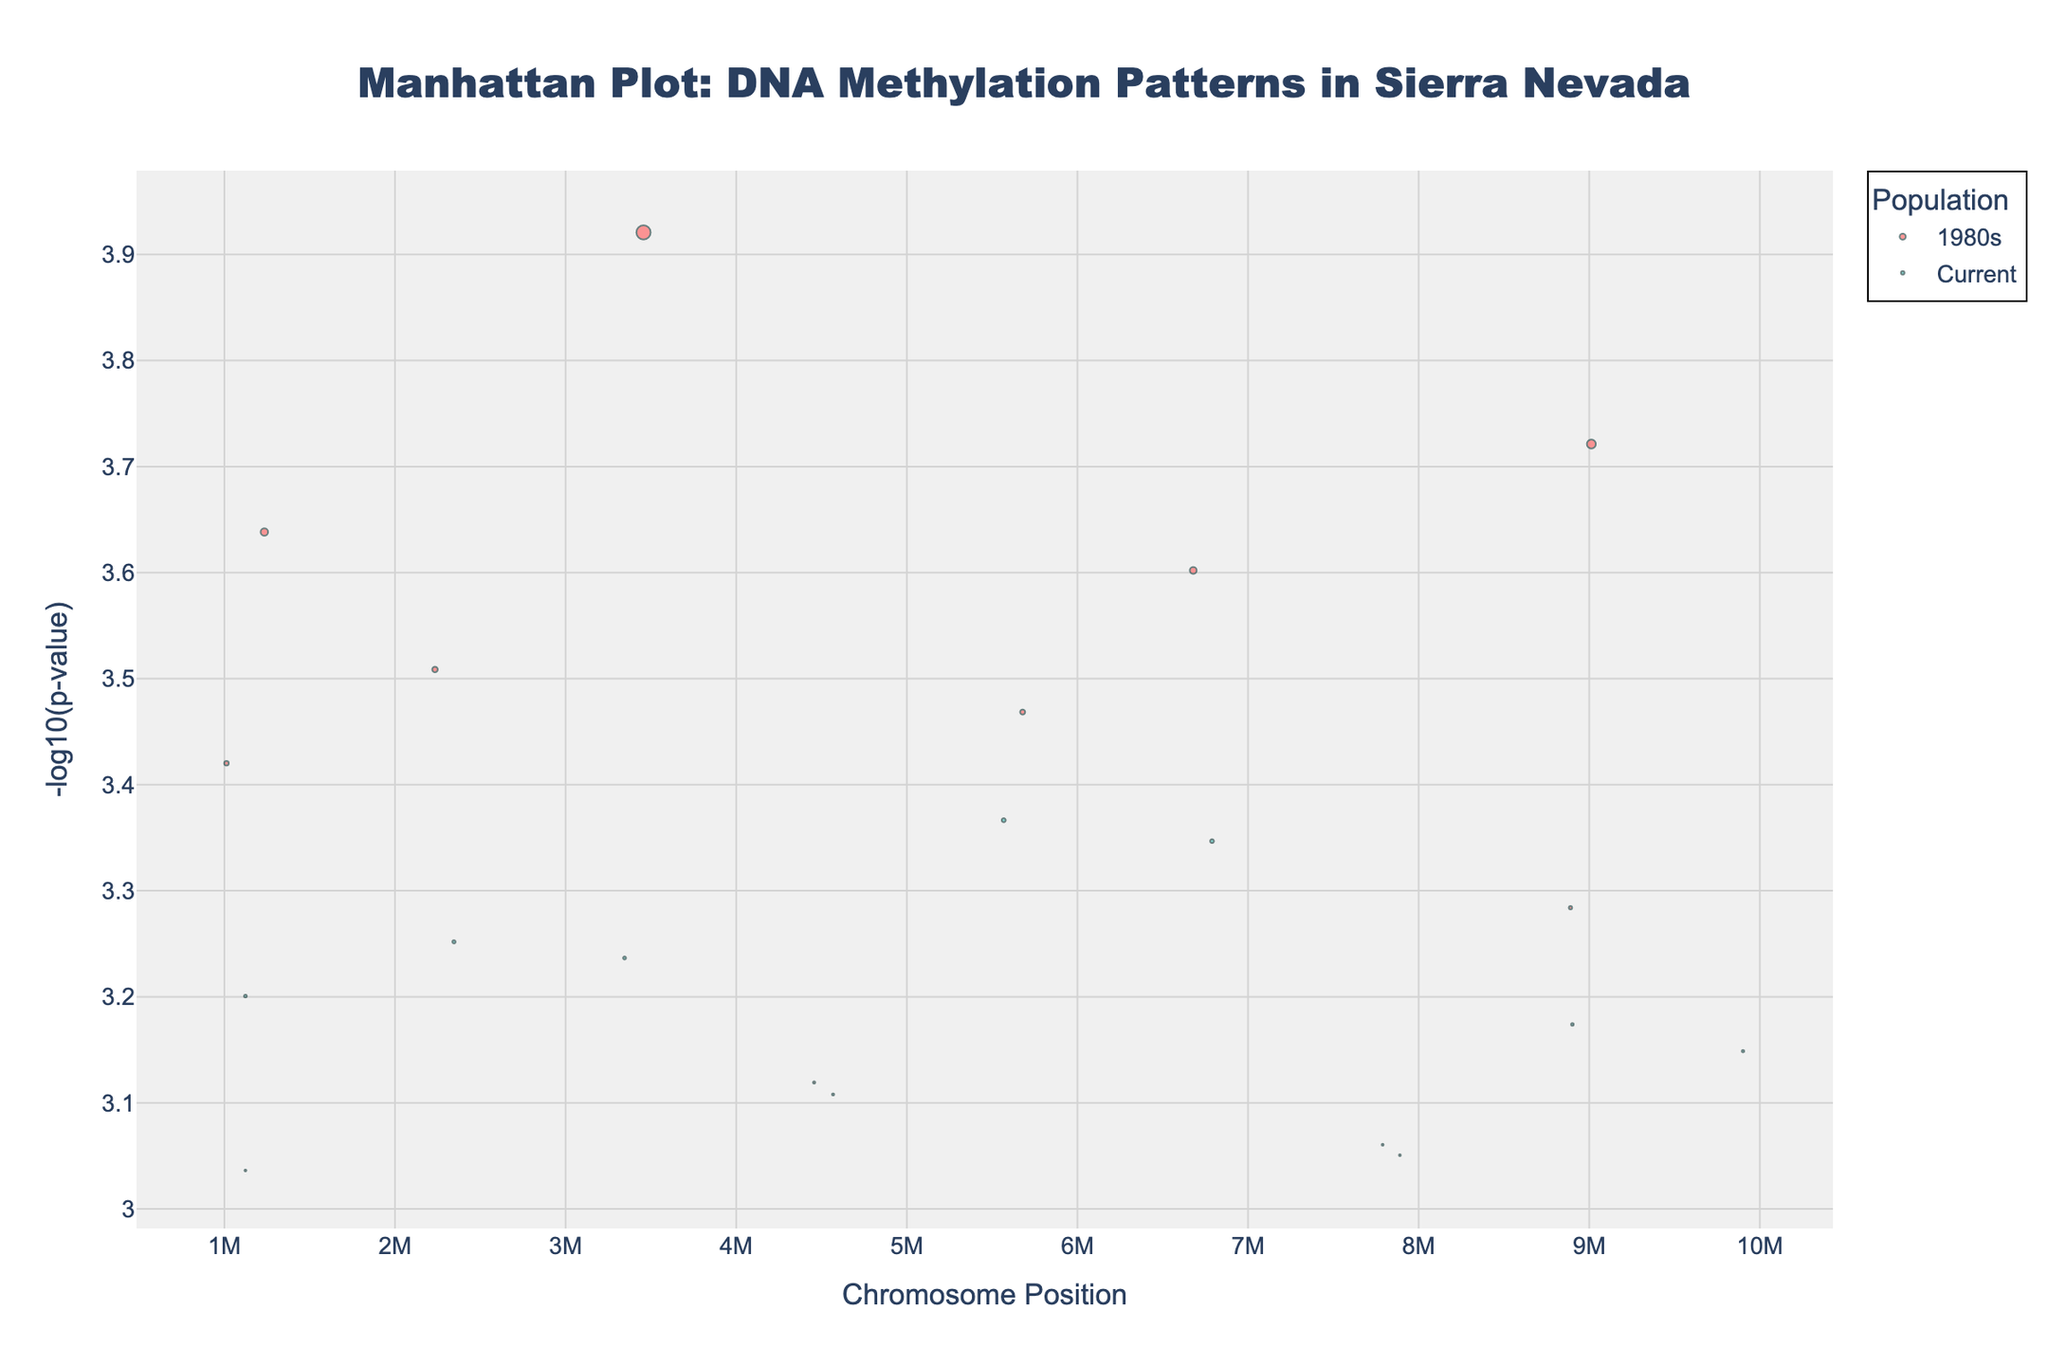What's the title of the figure? The title of the figure is located at the top center. It reads "Manhattan Plot: DNA Methylation Patterns in Sierra Nevada".
Answer: "Manhattan Plot: DNA Methylation Patterns in Sierra Nevada" What are the labels for the axes? The x-axis label is "Chromosome Position" and the y-axis label is "-log10(p-value)". These labels indicate what each axis represents.
Answer: "Chromosome Position" and "-log10(p-value)" How many different populations are represented in the plot? By looking at the legend on the right side of the figure, we can see there are two populations: "1980s" and "Current".
Answer: 2 Which population has data points represented by a pinkish color? According to the legend, the pinkish color is associated with the population "1980s".
Answer: 1980s Which gene has the lowest p-value in the `1980s` population? The y-axis represents the -log10(p-value), so the highest point on the y-axis corresponds to the lowest p-value. The highest point for the '1980s' population shows the gene `EPAS1`.
Answer: EPAS1 Compare the p-values of `EGLN1` and `EPAS1`. Which has a stronger association? The -log10(p-value) for `EPAS1` is higher than that of `EGLN1`, indicating a lower p-value and a stronger association for `EPAS1`.
Answer: EPAS1 What is the chromosomal position of the `NOS3` gene in the `1980s` population? By examining the figure and the corresponding points on the x-axis for the `1980s` population, the `NOS3` gene is located at position 7,890,123 on chromosome 4.
Answer: 7,890,123 Which gene has the highest p-value in the `1980s` population? The gene with the smallest value on the y-axis (i.e., lowest -log10(p-value)) has the highest p-value. For the `1980s` population, the gene `NOS3` shows the lowest -log10(p-value).
Answer: NOS3 For the gene `ANGPT1`, compare the p-values between the `1980s` and `Current` populations. Is this gene more significant in one population? The `ANGPT1` gene is only plotted for the `1980s` population, meaning it isn't plotted for `Current`, indicating a significant association is only found in the `1980s` population.
Answer: 1980s only Which gene related to high-altitude adaptation is highlighted in both populations? The gene `EGLN1` is highlighted in both populations. It is represented by points in both colors (pinkish for 1980s and greenish for Current).
Answer: EGLN1 